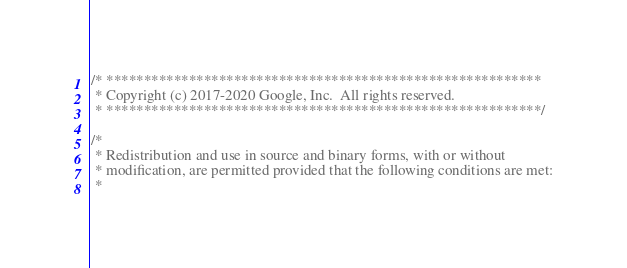<code> <loc_0><loc_0><loc_500><loc_500><_C++_>/* **********************************************************
 * Copyright (c) 2017-2020 Google, Inc.  All rights reserved.
 * **********************************************************/

/*
 * Redistribution and use in source and binary forms, with or without
 * modification, are permitted provided that the following conditions are met:
 *</code> 